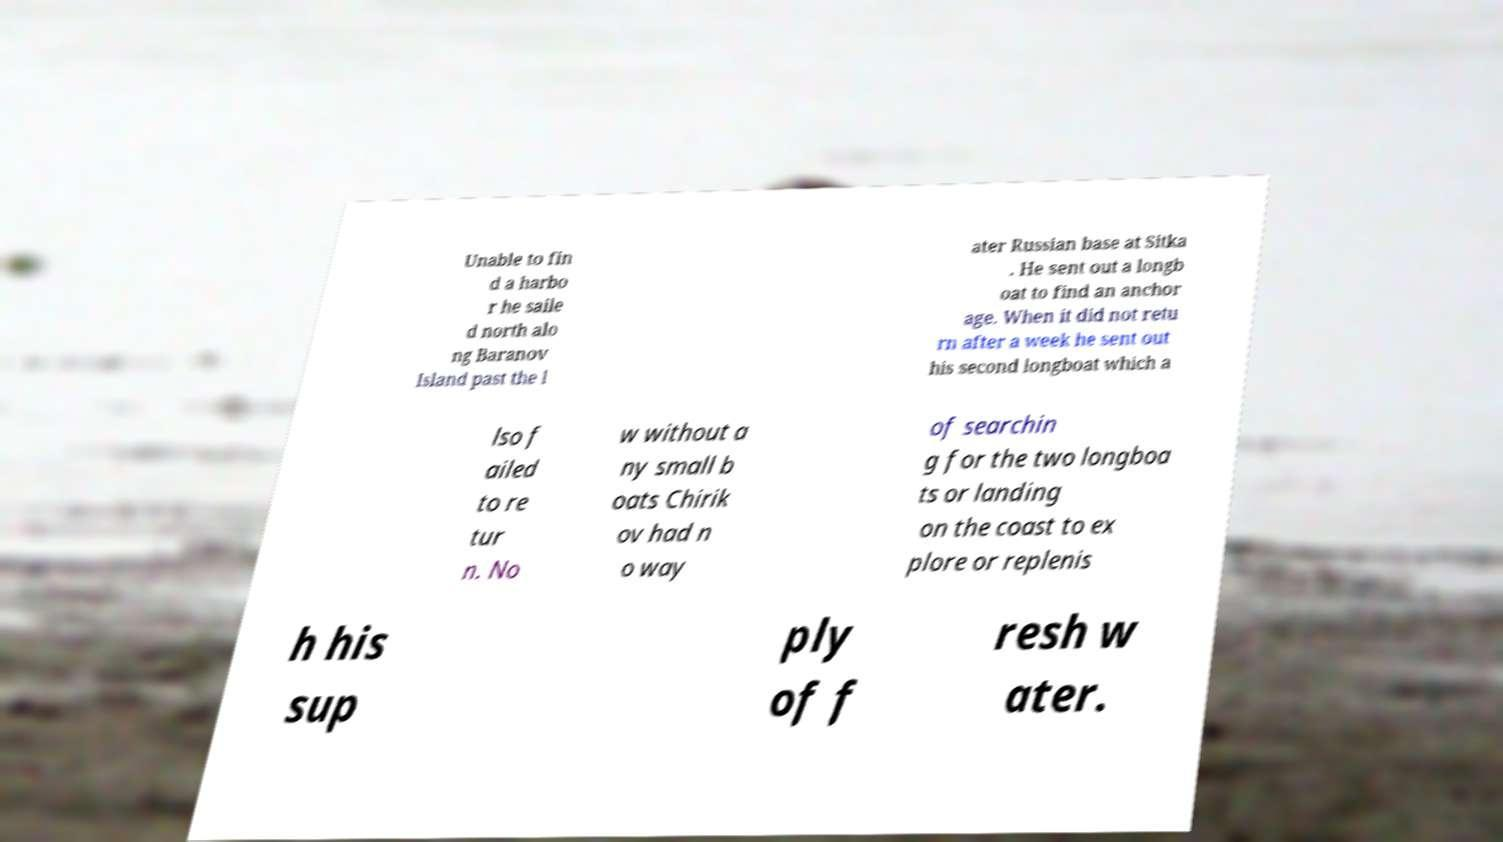Could you assist in decoding the text presented in this image and type it out clearly? Unable to fin d a harbo r he saile d north alo ng Baranov Island past the l ater Russian base at Sitka . He sent out a longb oat to find an anchor age. When it did not retu rn after a week he sent out his second longboat which a lso f ailed to re tur n. No w without a ny small b oats Chirik ov had n o way of searchin g for the two longboa ts or landing on the coast to ex plore or replenis h his sup ply of f resh w ater. 